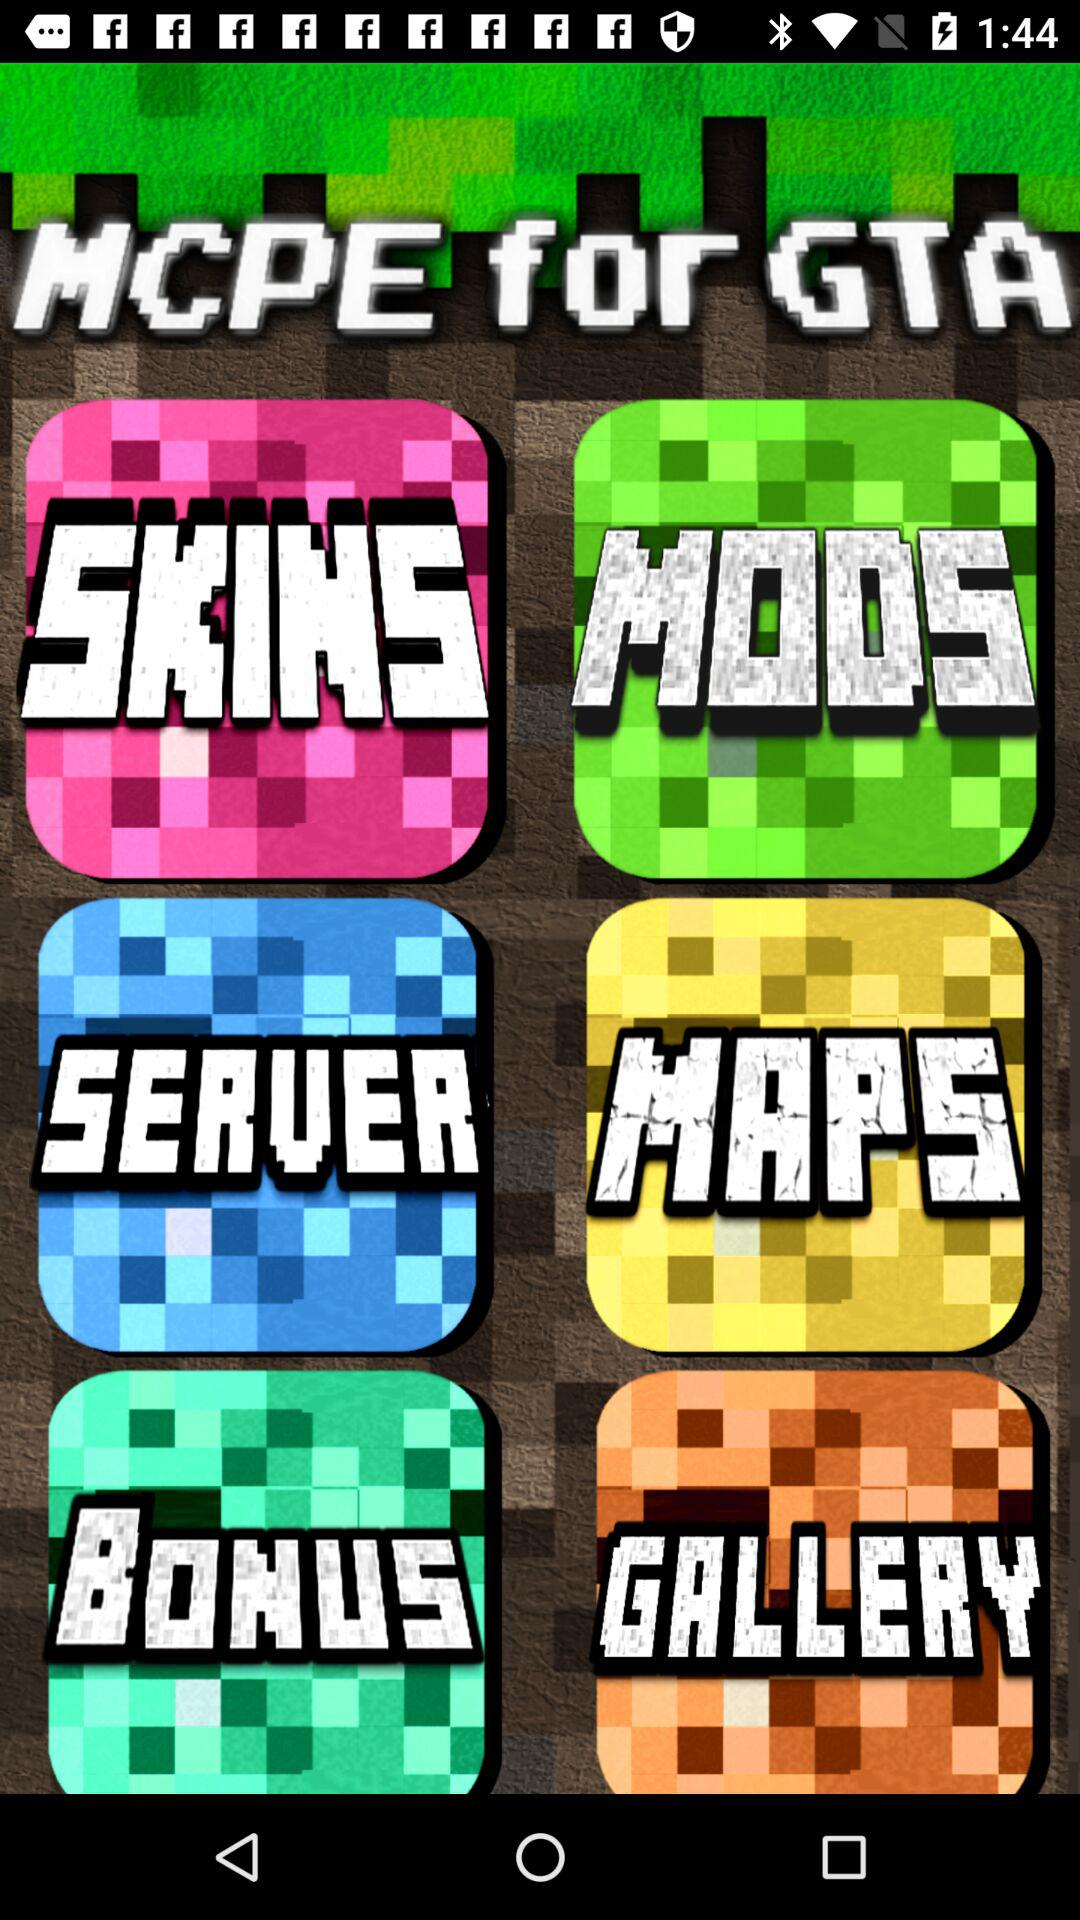What is the name of the application? The name of the application is "MCPE for GTA ". 